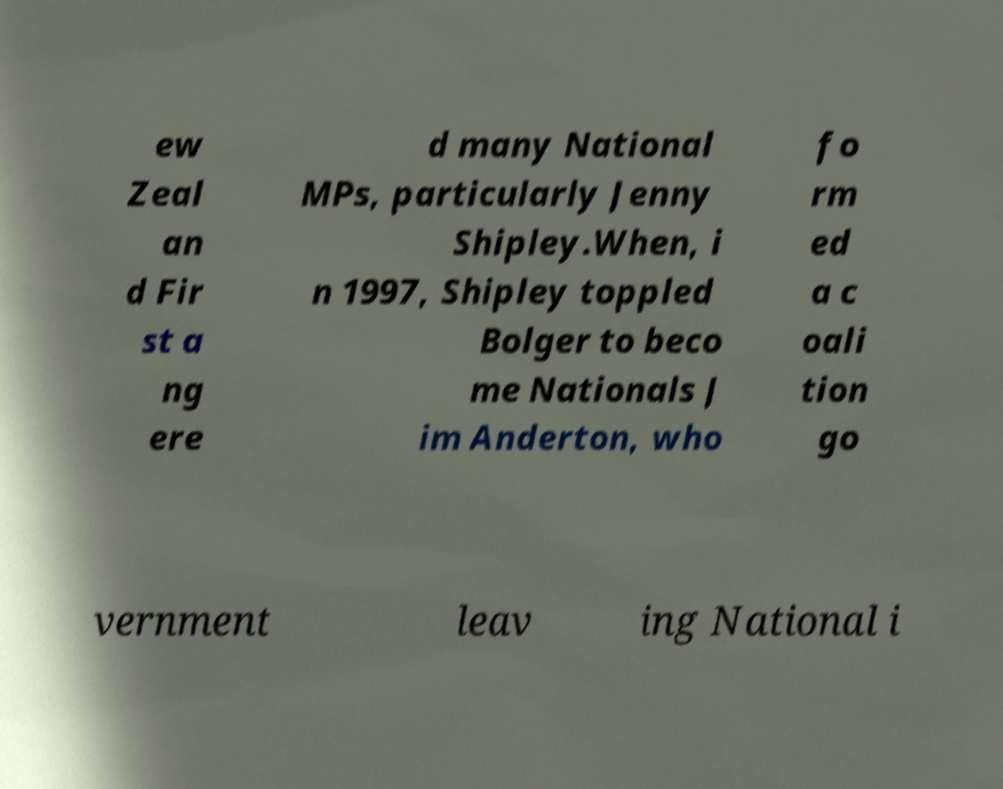For documentation purposes, I need the text within this image transcribed. Could you provide that? ew Zeal an d Fir st a ng ere d many National MPs, particularly Jenny Shipley.When, i n 1997, Shipley toppled Bolger to beco me Nationals J im Anderton, who fo rm ed a c oali tion go vernment leav ing National i 